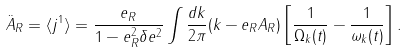Convert formula to latex. <formula><loc_0><loc_0><loc_500><loc_500>\ddot { A } _ { R } = \langle j ^ { 1 } \rangle = \frac { e _ { R } } { 1 - e ^ { 2 } _ { R } \delta e ^ { 2 } } \int \frac { d k } { 2 \pi } ( k - e _ { R } A _ { R } ) \left [ \frac { 1 } { \Omega _ { k } ( t ) } - \frac { 1 } { \omega _ { k } ( t ) } \right ] .</formula> 